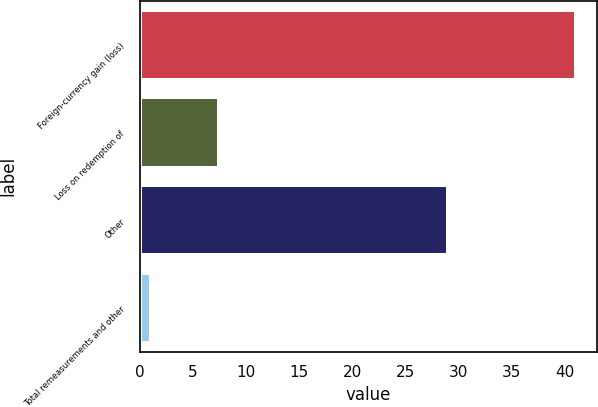Convert chart to OTSL. <chart><loc_0><loc_0><loc_500><loc_500><bar_chart><fcel>Foreign-currency gain (loss)<fcel>Loss on redemption of<fcel>Other<fcel>Total remeasurements and other<nl><fcel>41<fcel>7.4<fcel>29<fcel>1<nl></chart> 